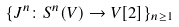<formula> <loc_0><loc_0><loc_500><loc_500>\{ J ^ { n } \colon S ^ { n } ( V ) \to V [ 2 ] \} _ { n \geq 1 }</formula> 